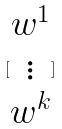Convert formula to latex. <formula><loc_0><loc_0><loc_500><loc_500>[ \begin{matrix} w ^ { 1 } \\ \vdots \\ w ^ { k } \end{matrix} ]</formula> 